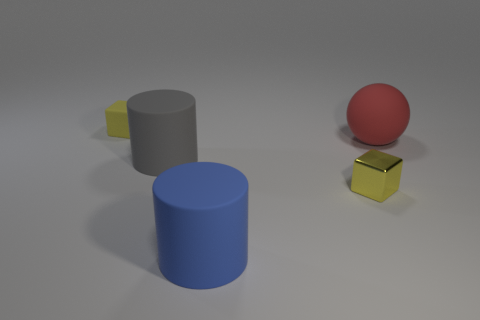There is a thing that is both on the left side of the big blue matte thing and in front of the large red rubber sphere; what is its size?
Offer a very short reply. Large. Are there any small objects in front of the large sphere?
Give a very brief answer. Yes. There is a big matte thing in front of the tiny metallic cube; is there a gray rubber object behind it?
Your response must be concise. Yes. Is the number of tiny cubes left of the tiny yellow matte cube the same as the number of large blue matte objects that are to the left of the large blue matte cylinder?
Keep it short and to the point. Yes. There is another cylinder that is the same material as the large gray cylinder; what color is it?
Your answer should be very brief. Blue. Is there a cyan cube made of the same material as the gray object?
Provide a succinct answer. No. How many things are small red metal balls or cubes?
Your answer should be compact. 2. Does the big blue cylinder have the same material as the tiny object that is right of the gray matte cylinder?
Provide a short and direct response. No. There is a object that is in front of the tiny metallic thing; how big is it?
Ensure brevity in your answer.  Large. Is the number of purple cylinders less than the number of gray objects?
Provide a succinct answer. Yes. 